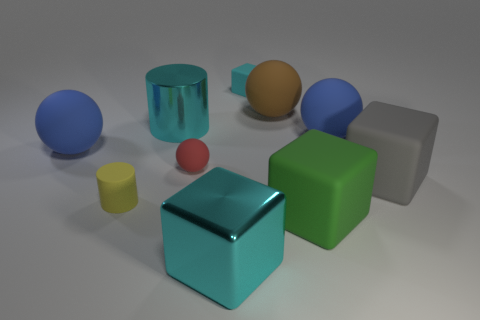Is the big gray object made of the same material as the blue sphere to the left of the large green rubber thing?
Provide a succinct answer. Yes. How many other things are the same shape as the tiny red thing?
Your answer should be compact. 3. How many objects are gray matte objects behind the green cube or matte spheres left of the large green rubber block?
Offer a very short reply. 4. What number of other things are there of the same color as the large shiny cube?
Ensure brevity in your answer.  2. Is the number of metal cubes behind the tiny cyan matte cube less than the number of objects behind the brown object?
Make the answer very short. Yes. What number of small gray cylinders are there?
Make the answer very short. 0. Is there anything else that has the same material as the red sphere?
Your response must be concise. Yes. There is a large object that is the same shape as the tiny yellow thing; what material is it?
Give a very brief answer. Metal. Are there fewer big cyan metallic objects behind the cyan cylinder than cyan shiny cubes?
Give a very brief answer. Yes. There is a cyan object behind the large brown rubber sphere; does it have the same shape as the tiny red thing?
Ensure brevity in your answer.  No. 